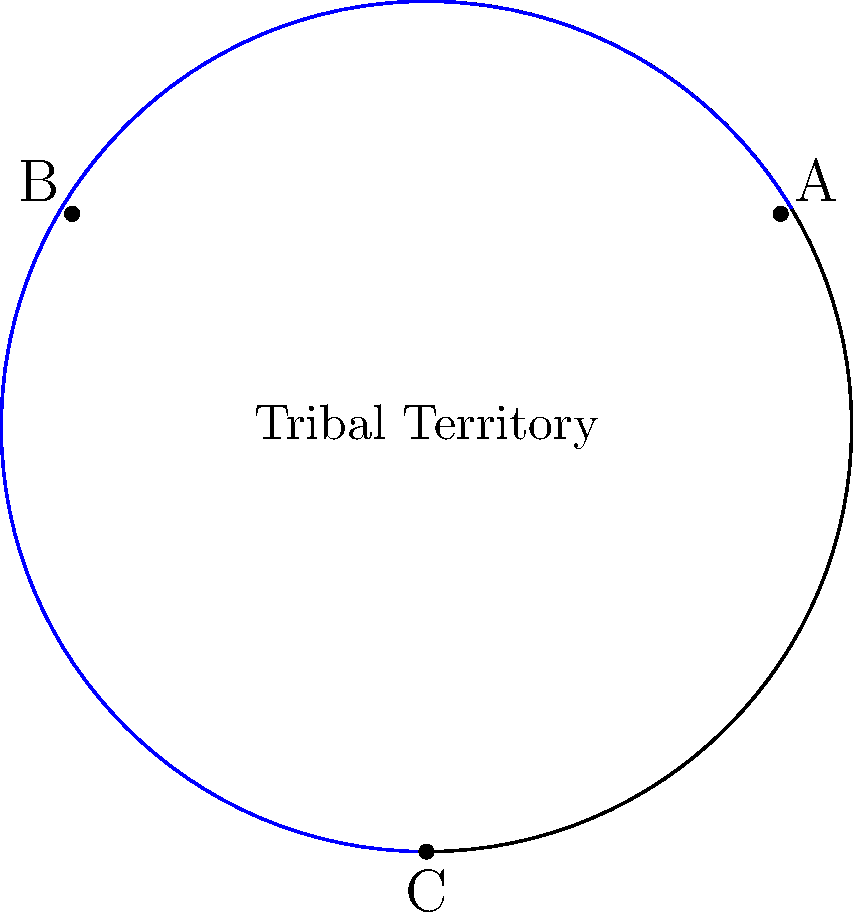Three sacred landmarks A, B, and C form a triangle on your curved tribal territory, represented by a sphere. If the sum of the interior angles of this triangle is measured to be 230°, what is the area of the triangle relative to the total surface area of your territory? To solve this problem, we'll use concepts from spherical geometry:

1) In spherical geometry, the sum of interior angles of a triangle is always greater than 180°. The excess over 180° is directly proportional to the area of the triangle.

2) Let E be the excess: E = (Sum of angles) - 180°
   Here, E = 230° - 180° = 50°

3) The area of a spherical triangle is given by the formula:
   Area = R² * E (in radians), where R is the radius of the sphere

4) We need to convert 50° to radians:
   50° * (π/180°) ≈ 0.8727 radians

5) The area of the triangle is thus:
   Area = R² * 0.8727

6) The total surface area of a sphere is 4πR²

7) The relative area is:
   Relative Area = (R² * 0.8727) / (4πR²) = 0.8727 / (4π) ≈ 0.0694

8) Converting to a percentage:
   0.0694 * 100% ≈ 6.94%

Therefore, the area of the triangle is approximately 6.94% of the total surface area of the tribal territory.
Answer: 6.94% of the total surface area 